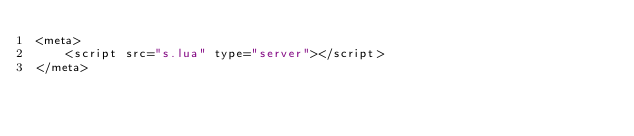Convert code to text. <code><loc_0><loc_0><loc_500><loc_500><_XML_><meta>
    <script src="s.lua" type="server"></script>
</meta>
</code> 